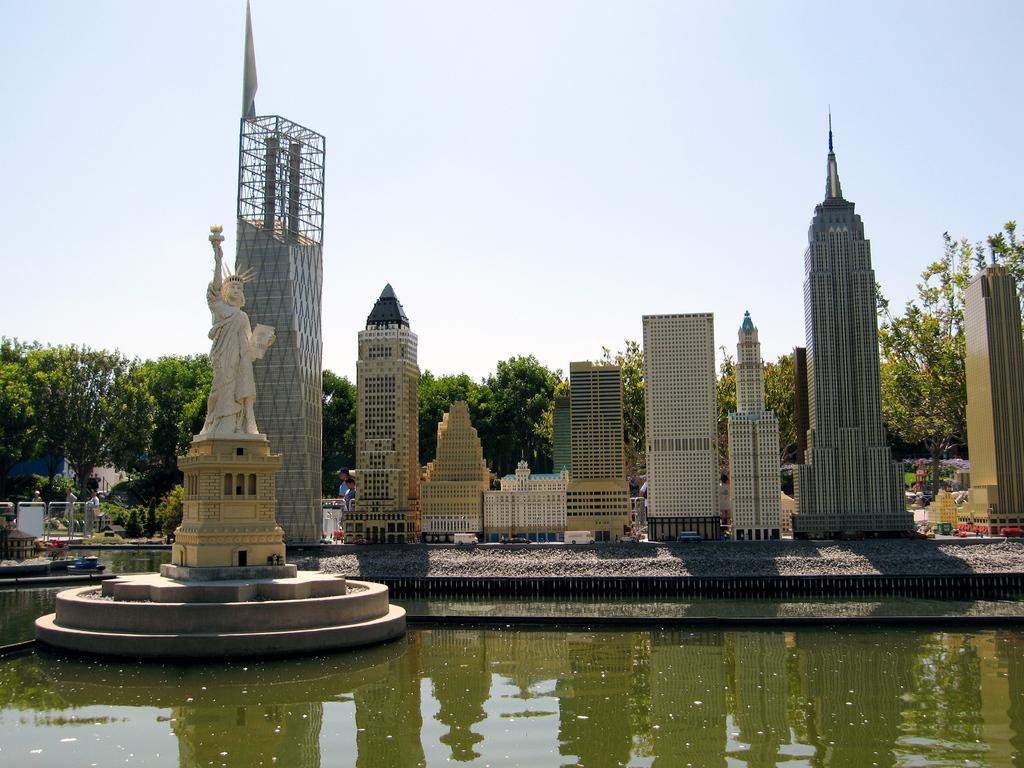In one or two sentences, can you explain what this image depicts? In this picture there is a statue on the left side of the image and there is water at the bottom side of the image, there are trees and buildings in the center of the image. 